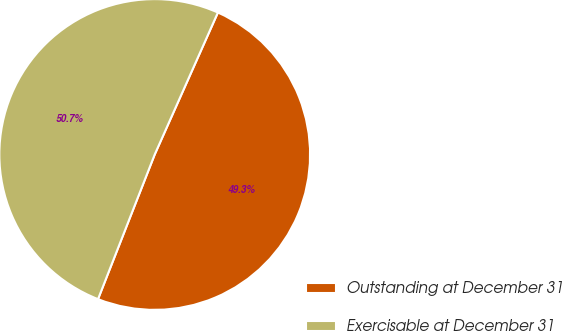<chart> <loc_0><loc_0><loc_500><loc_500><pie_chart><fcel>Outstanding at December 31<fcel>Exercisable at December 31<nl><fcel>49.28%<fcel>50.72%<nl></chart> 